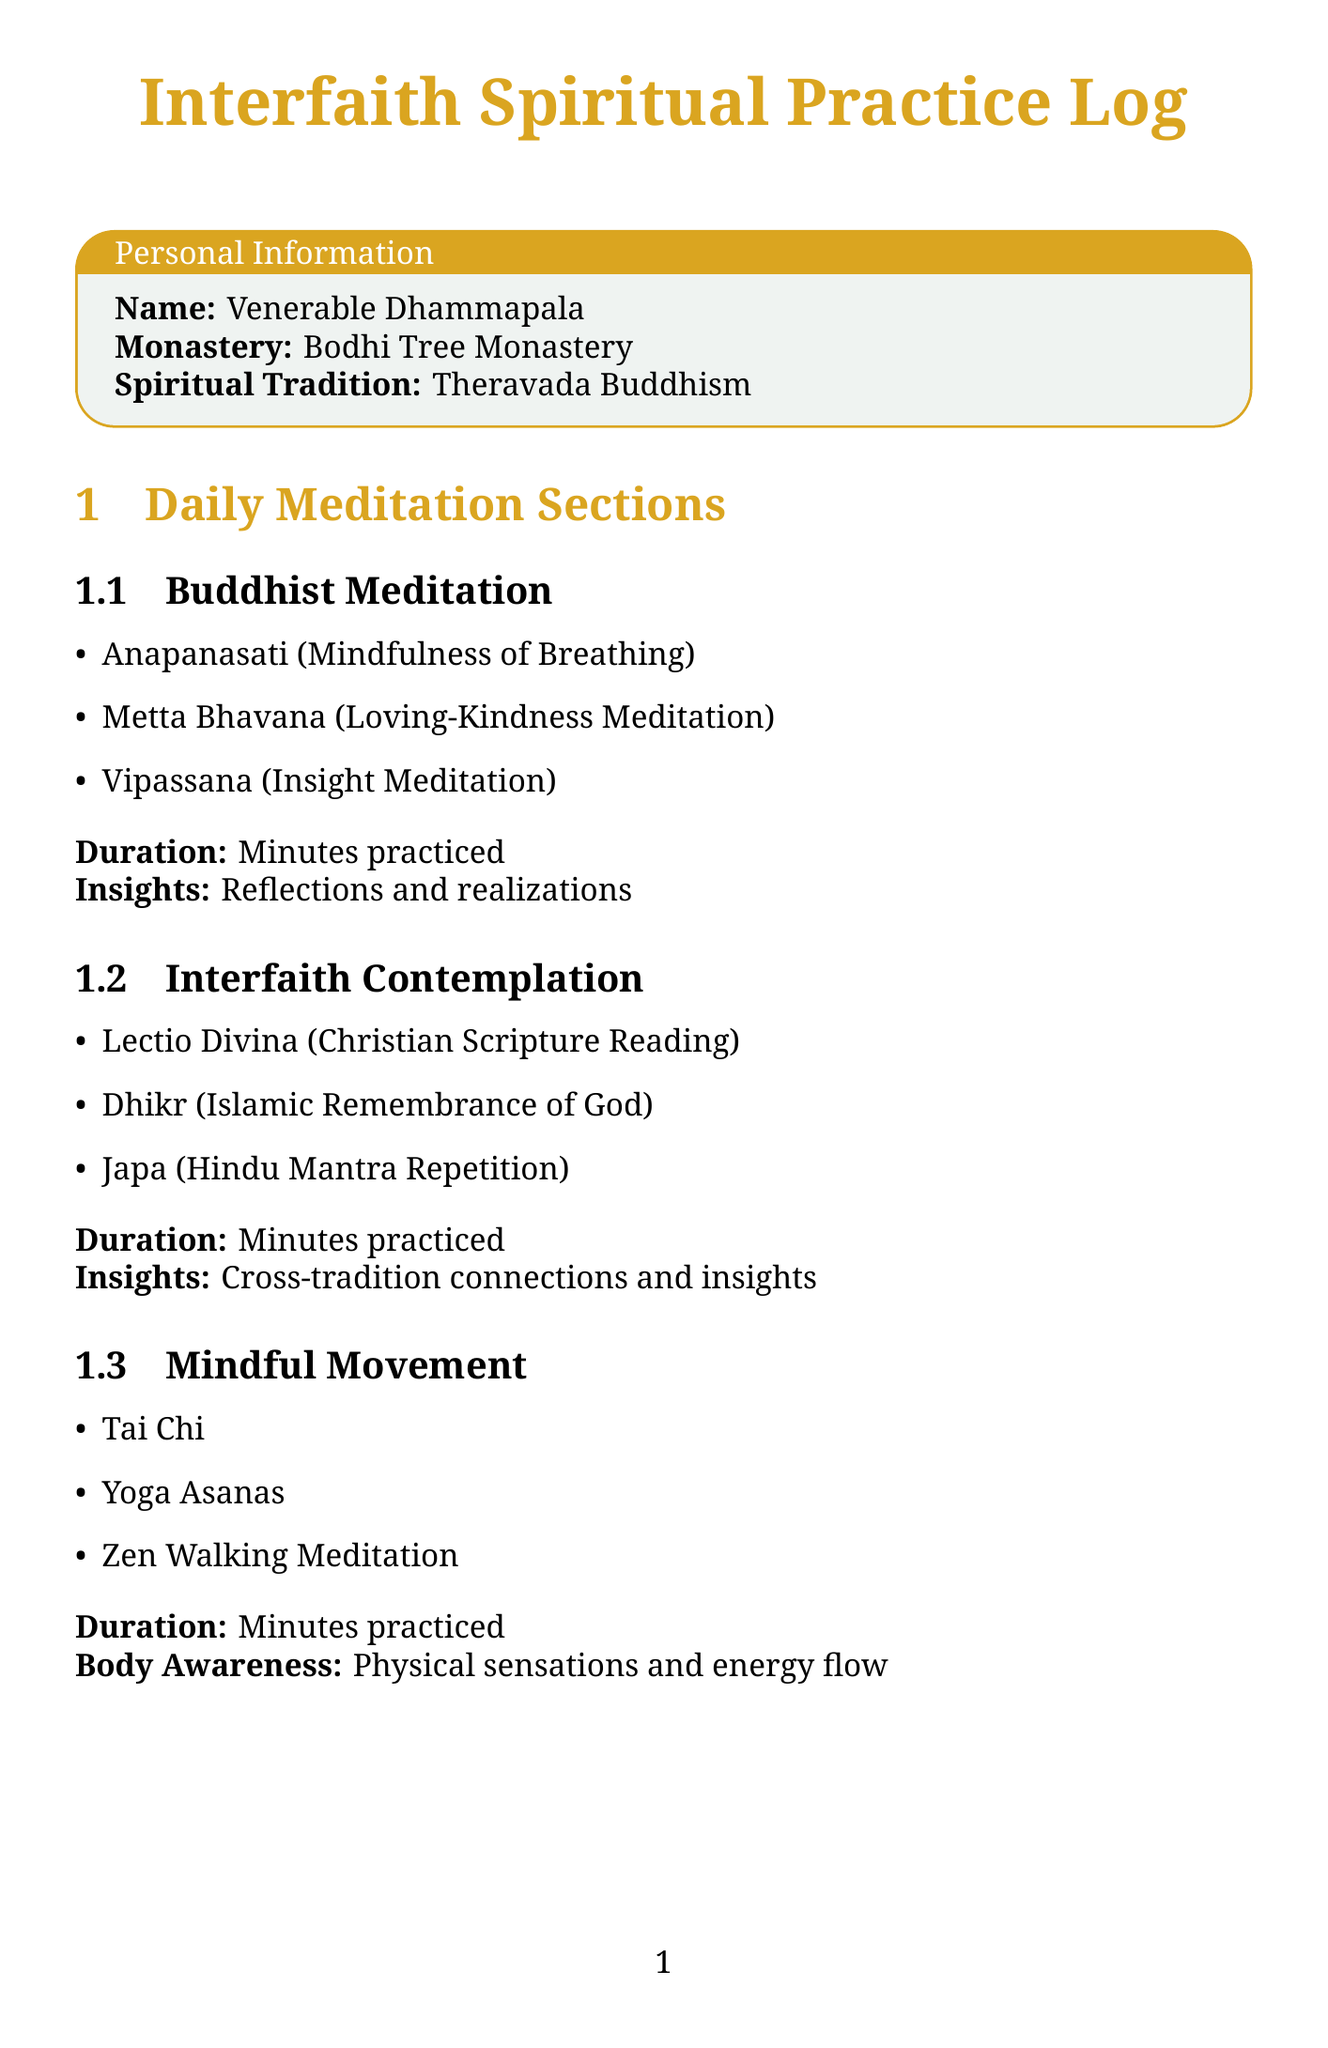What is the title of the document? The title of the document is presented in a prominent position in the header.
Answer: Interfaith Spiritual Practice Log Who is the author of this log? The author's name is given in the personal information section.
Answer: Venerable Dhammapala What spiritual tradition does the author follow? The spiritual tradition is listed directly under the author's name in the personal information.
Answer: Theravada Buddhism How many sections are there in the daily meditation log? The sections are enumerated in the "Daily Meditation Sections" heading.
Answer: Three What practice is included in the Buddhist Meditation section? The practices in each section are listed in bullet points.
Answer: Anapanasati (Mindfulness of Breathing) What is the prompt for integrating teachings? The prompts for reflection are provided under their respective sections.
Answer: How did today's practices from different traditions complement each other? Which resource mentions 'Dhammapada'? The resources are categorized under different headings, with scriptures listed.
Answer: Scriptures What is the focus of the 'Mindful Movement' section? This section describes various practices related to physical and energetic awareness.
Answer: Physical sensations and energy flow List one interfaith center mentioned in the document. The interfaith centers are listed in their own category.
Answer: Plum Village (France) What is the answer format for the response space in the Ethical Conduct section? The response space format is specified under each reflection prompt.
Answer: Write your reflections here 